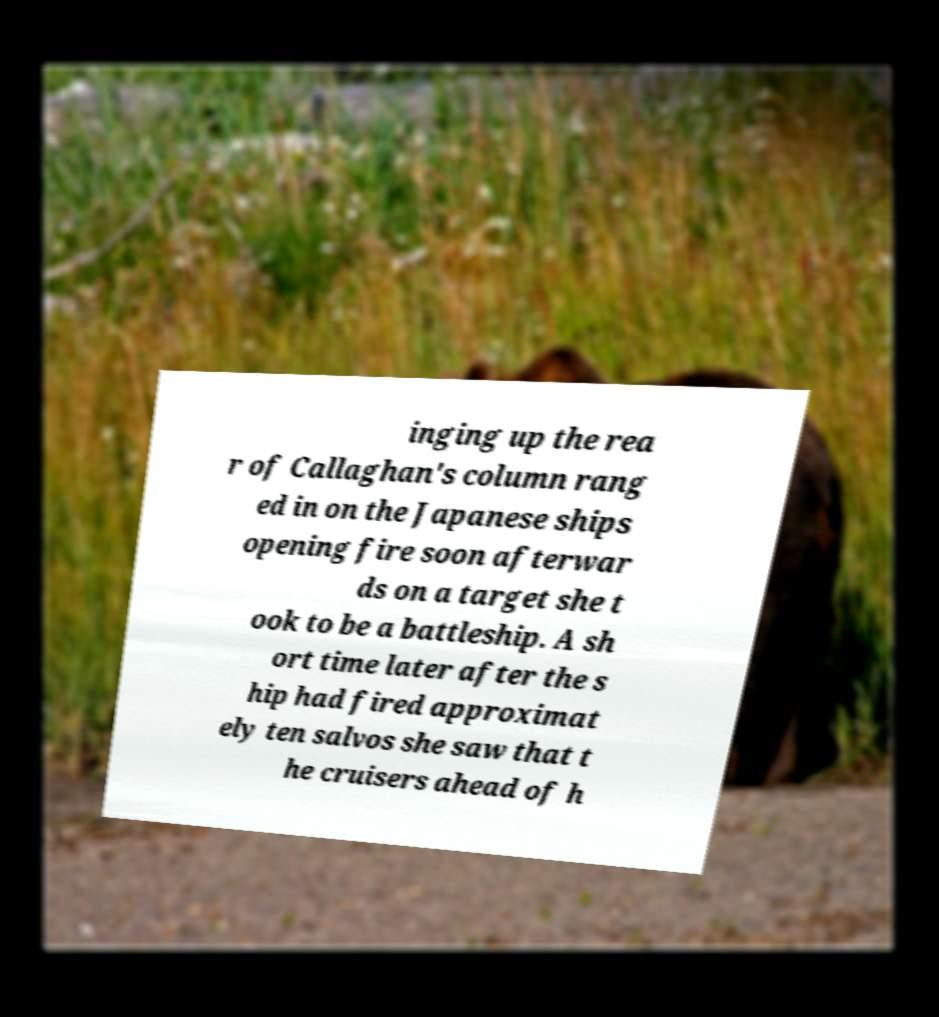For documentation purposes, I need the text within this image transcribed. Could you provide that? inging up the rea r of Callaghan's column rang ed in on the Japanese ships opening fire soon afterwar ds on a target she t ook to be a battleship. A sh ort time later after the s hip had fired approximat ely ten salvos she saw that t he cruisers ahead of h 